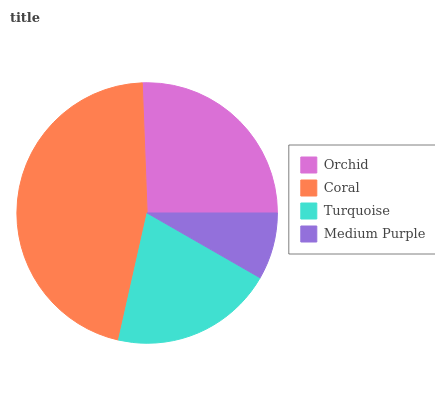Is Medium Purple the minimum?
Answer yes or no. Yes. Is Coral the maximum?
Answer yes or no. Yes. Is Turquoise the minimum?
Answer yes or no. No. Is Turquoise the maximum?
Answer yes or no. No. Is Coral greater than Turquoise?
Answer yes or no. Yes. Is Turquoise less than Coral?
Answer yes or no. Yes. Is Turquoise greater than Coral?
Answer yes or no. No. Is Coral less than Turquoise?
Answer yes or no. No. Is Orchid the high median?
Answer yes or no. Yes. Is Turquoise the low median?
Answer yes or no. Yes. Is Medium Purple the high median?
Answer yes or no. No. Is Medium Purple the low median?
Answer yes or no. No. 